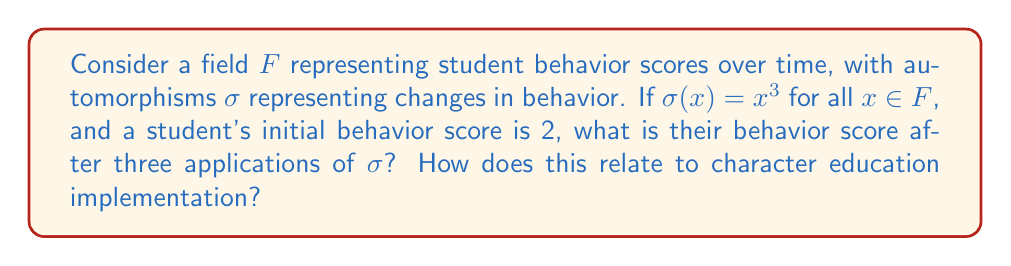Can you answer this question? 1) Let's start with the initial behavior score of 2.

2) Apply $\sigma$ once:
   $\sigma(2) = 2^3 = 8$

3) Apply $\sigma$ again:
   $\sigma(8) = 8^3 = 512$

4) Apply $\sigma$ for the third time:
   $\sigma(512) = 512^3 = 134,217,728$

5) The final behavior score after three applications of $\sigma$ is 134,217,728.

6) Relating to character education:
   This exponential growth in the behavior score could represent the compounding positive effects of consistent character education implementation over time. Each application of $\sigma$ (representing a period of character education) leads to a significant improvement in behavior scores, demonstrating the potential long-term impact of integrating character education into curriculum standards.

7) However, it's important to note that this is a simplified mathematical model. In reality, behavior changes would likely follow a more complex pattern and be influenced by various factors beyond just the implementation of character education programs.
Answer: 134,217,728 